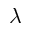<formula> <loc_0><loc_0><loc_500><loc_500>\lambda</formula> 